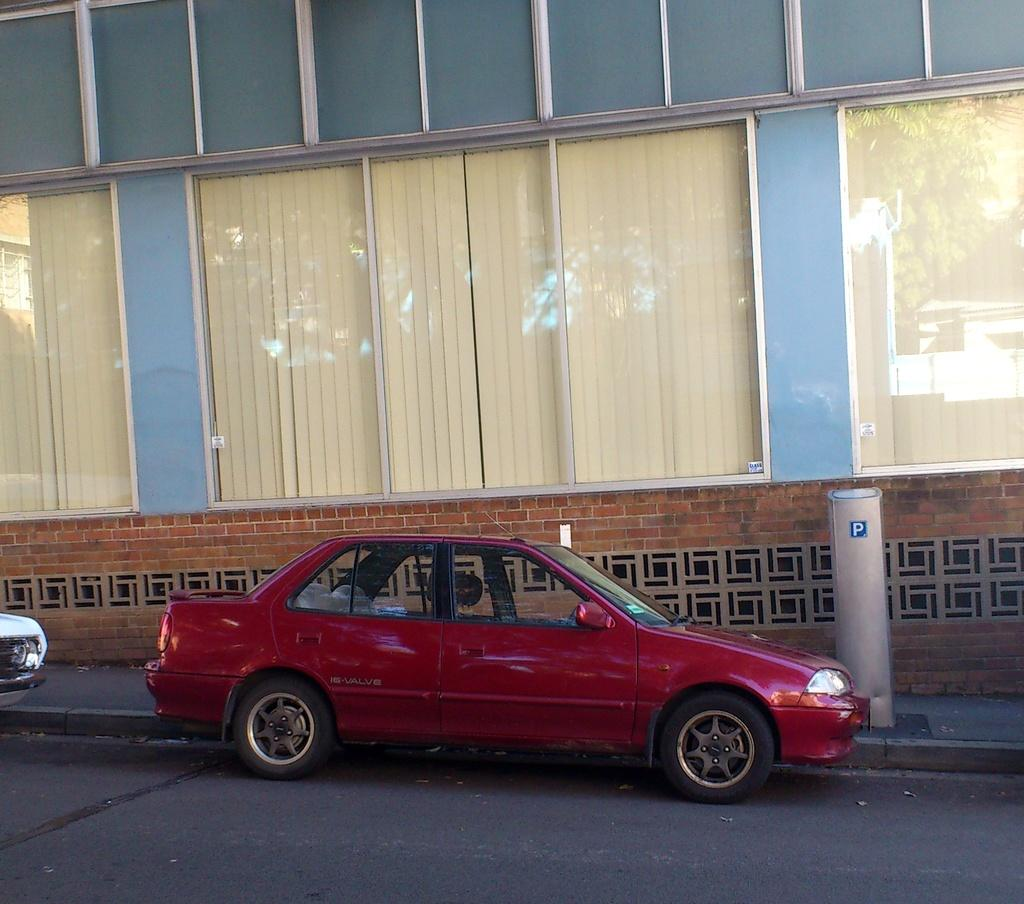What can be seen on the road in the image? There are vehicles on the road in the image. What is attached to a pole in the image? There is a sticker on a pole in the image. What type of structure is present in the image? There is a building in the image. What type of windows are visible in the image? There are glass windows visible in the image. What type of window covering is present in the image? Window blinds are present in the image. What can be seen on the glass windows in the image? There is a reflection visible on the glass windows in the image. What type of chain can be seen hanging from the building in the image? There is no chain hanging from the building in the image. What type of lunch is being served in the image? There is no lunch being served in the image. 